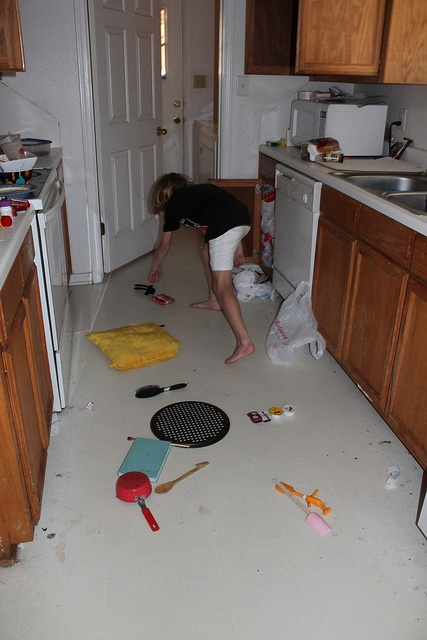Describe the objects in this image and their specific colors. I can see people in maroon, black, gray, and darkgray tones, oven in maroon, gray, darkgray, black, and lightgray tones, microwave in maroon, gray, and black tones, sink in maroon, black, gray, and darkgray tones, and spoon in maroon, brown, and gray tones in this image. 